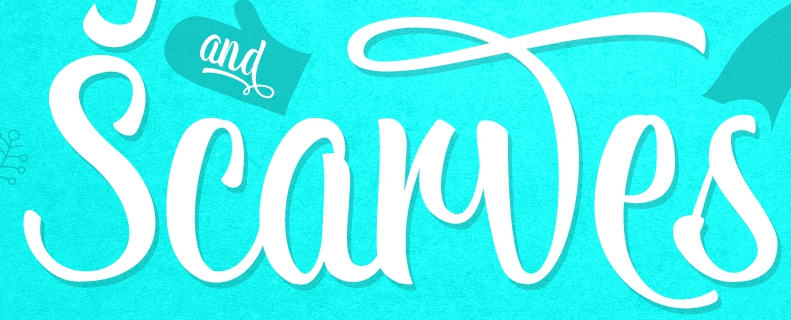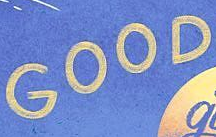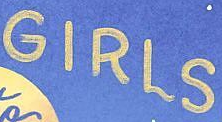Transcribe the words shown in these images in order, separated by a semicolon. Scarwes; GOOD; GIRLS 